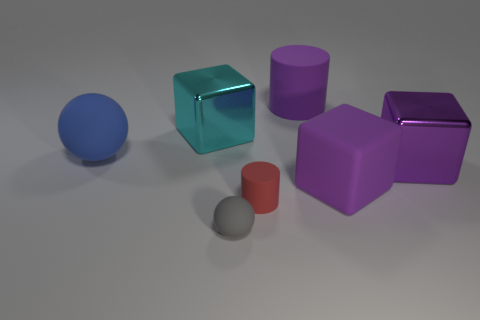Subtract all purple blocks. How many were subtracted if there are1purple blocks left? 1 Subtract all shiny cubes. How many cubes are left? 1 Subtract all purple cylinders. How many purple blocks are left? 2 Add 1 small spheres. How many objects exist? 8 Add 6 purple matte cubes. How many purple matte cubes exist? 7 Subtract 1 gray spheres. How many objects are left? 6 Subtract all cylinders. How many objects are left? 5 Subtract all cyan cubes. Subtract all brown cylinders. How many cubes are left? 2 Subtract all large gray cubes. Subtract all cyan shiny objects. How many objects are left? 6 Add 7 rubber blocks. How many rubber blocks are left? 8 